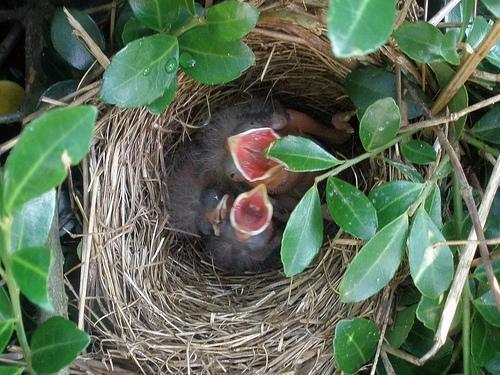How many birds are there?
Give a very brief answer. 3. How many birds have their mouth open?
Give a very brief answer. 2. How many bird nests are there?
Give a very brief answer. 1. 